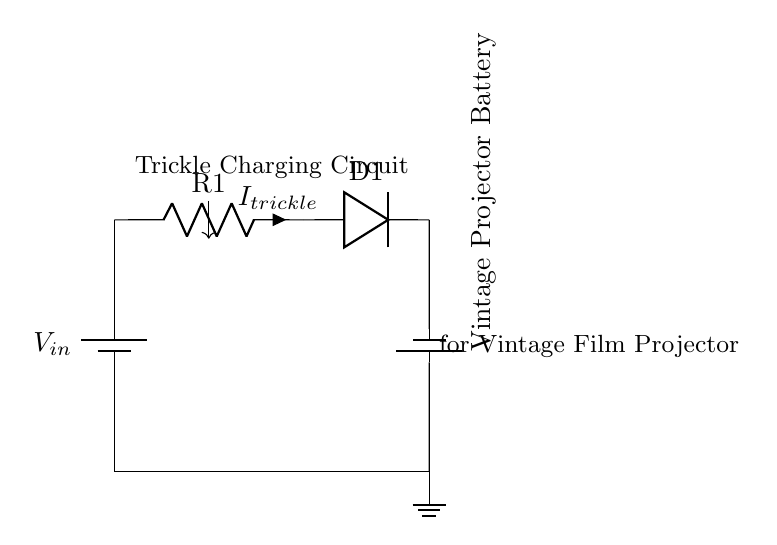What is the source of power in this circuit? The power source is indicated as a battery labeled \(V_{in}\) at the top left of the diagram.
Answer: Battery What is the role of the resistor labeled R1? The resistor R1 limits the current flowing into the battery, which is essential for trickle charging to prevent overcharging.
Answer: Current limiting What type of component is D1 in the circuit? D1 is a diode, which allows current to flow in one direction towards the battery and prevents backflow, ensuring safe charging.
Answer: Diode What is the purpose of this circuit? The primary purpose of this circuit is to trickle charge a vintage film projector battery, keeping it topped up without overcharging.
Answer: Trickle charging If the current through R1 is denoted \(I_{trickle}\), what does it represent? \(I_{trickle}\) represents the small, consistent current that is supplied to the battery for maintenance charging, ensuring it stays charged without damage.
Answer: Maintenance current Why is a diode necessary in this circuit? The diode prevents reverse current flow that could damage the battery, ensuring that only the correct polarity charges the battery.
Answer: Prevents reverse current How does this circuit ensure that the vintage projector battery does not overcharge? The combination of R1 as a current limiting resistor and D1 as a diode effectively controls and directs the flow of current, preventing the battery from receiving excess voltage or current.
Answer: Current limitation and diode protection 